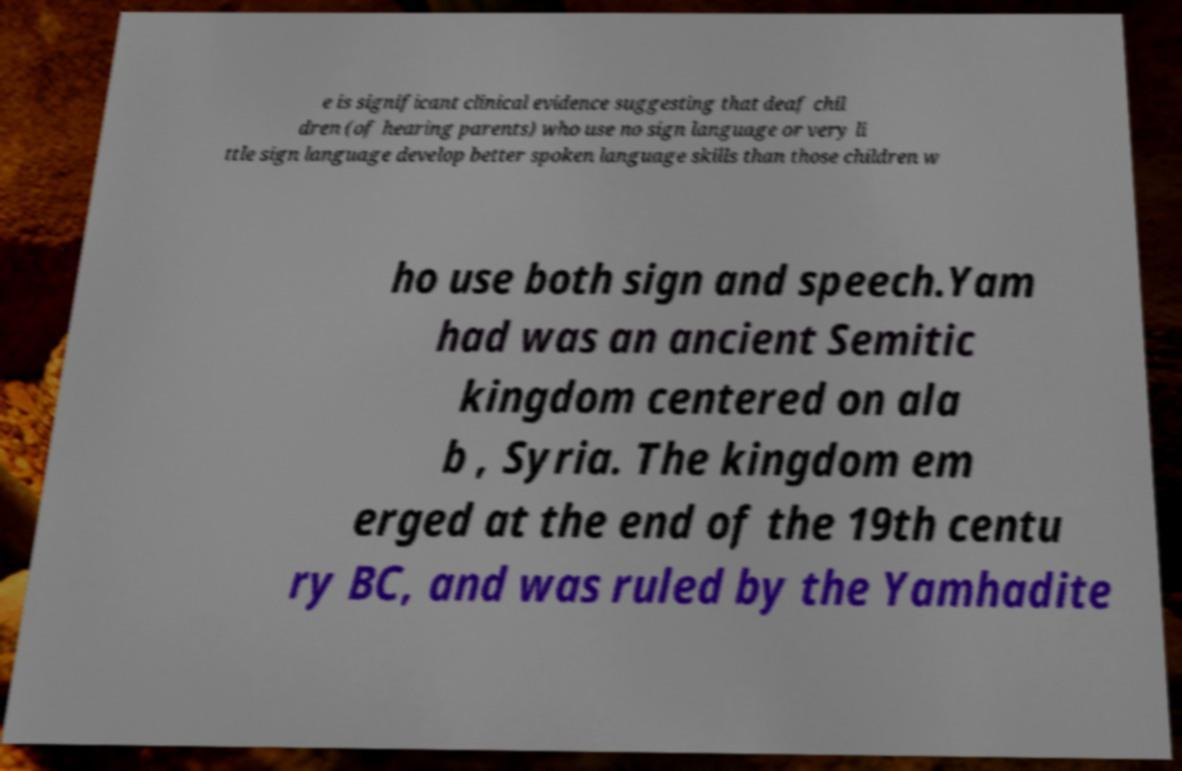Please read and relay the text visible in this image. What does it say? e is significant clinical evidence suggesting that deaf chil dren (of hearing parents) who use no sign language or very li ttle sign language develop better spoken language skills than those children w ho use both sign and speech.Yam had was an ancient Semitic kingdom centered on ala b , Syria. The kingdom em erged at the end of the 19th centu ry BC, and was ruled by the Yamhadite 